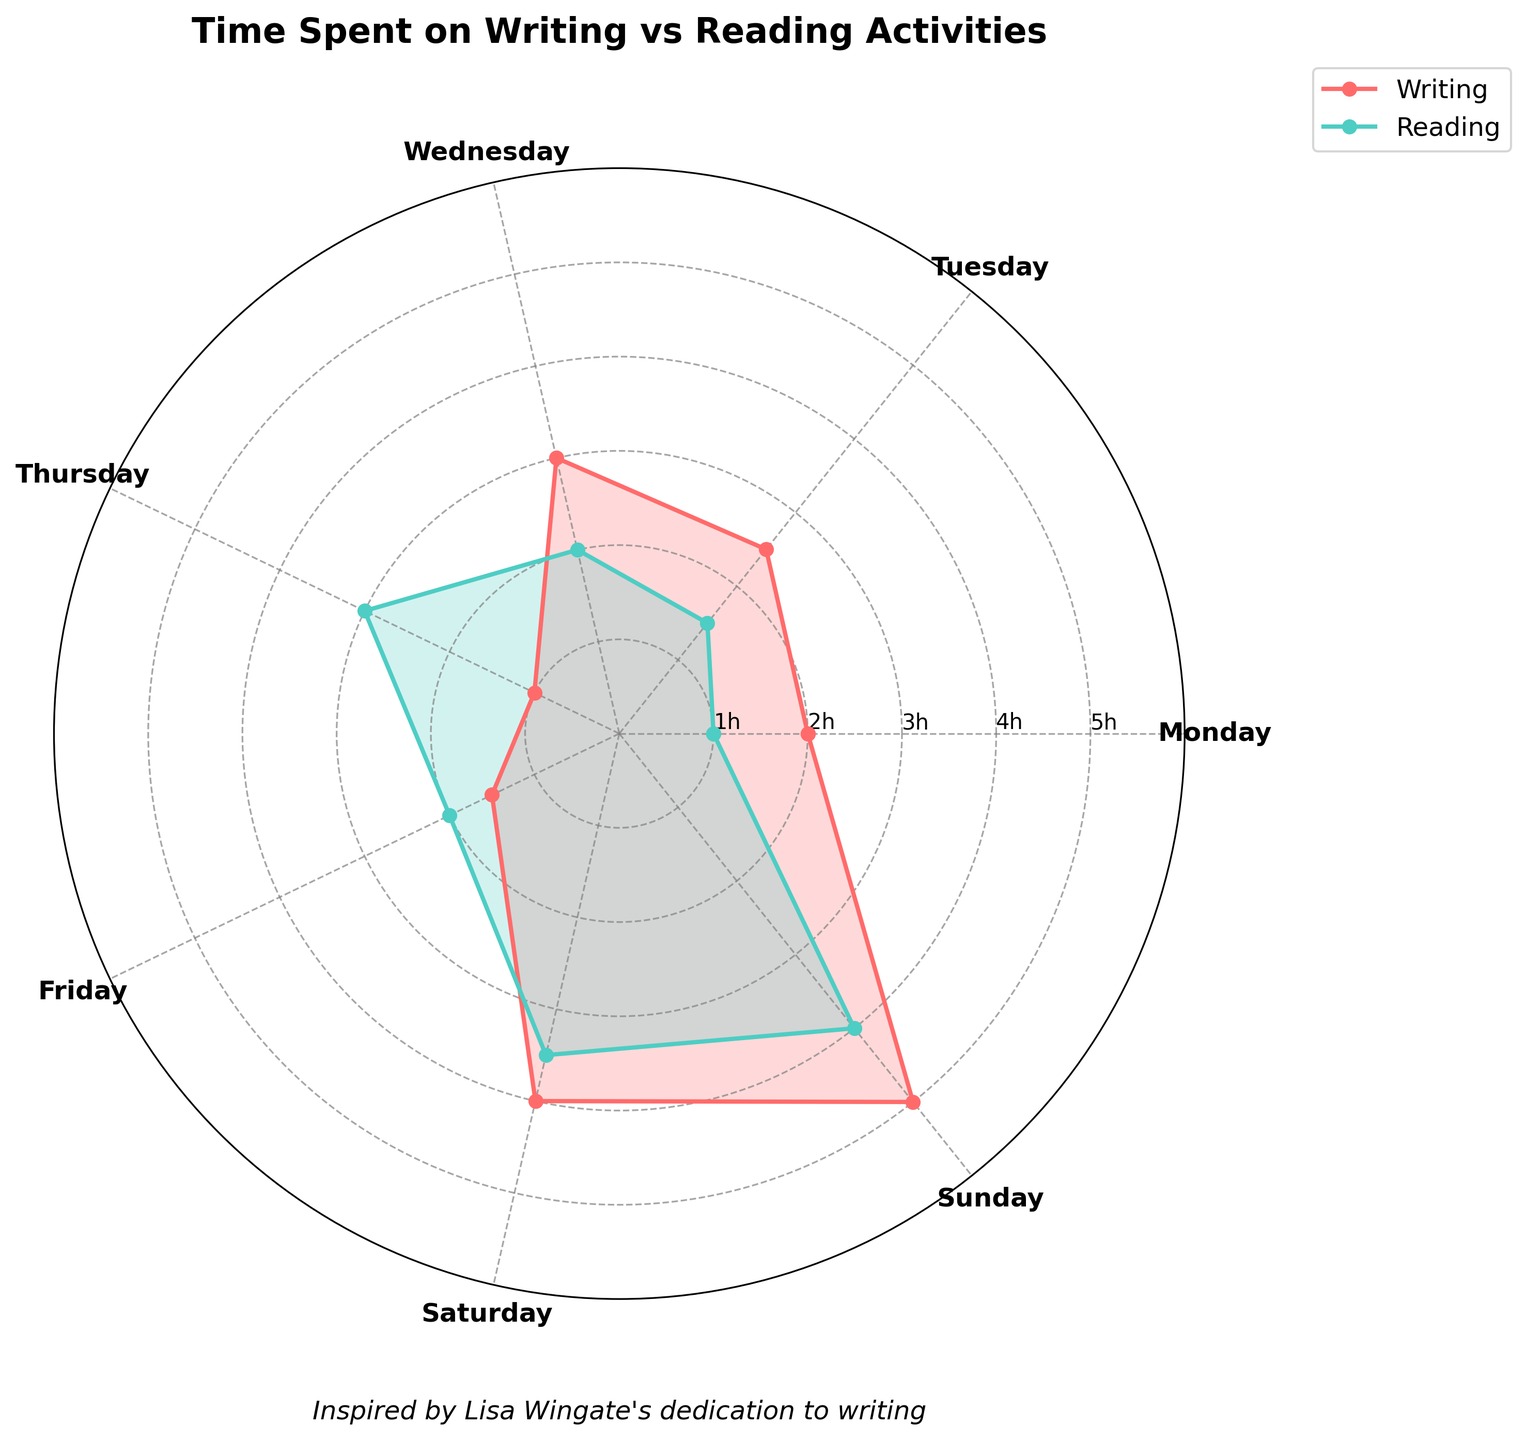What day has the highest number of hours dedicated to writing activities? The day with the highest number of hours dedicated to writing activities is Sunday. This can be observed as the plot shows the largest value for writing activities on Sunday.
Answer: Sunday How many more hours are spent on writing activities compared to reading activities on Wednesday? On Wednesday, 3 hours are spent on writing activities, and 2 hours on reading activities. Subtracting the reading hours from the writing hours gives us 3 - 2 = 1 hour.
Answer: 1 hour What is the total number of hours spent on both writing and reading activities on Thursday? On Thursday, 1 hour is spent on writing activities and 3 hours on reading activities. Summing these gives 1 + 3 = 4 hours.
Answer: 4 hours Which day has the smallest difference between writing and reading activities hours? To determine this, we should calculate the difference for each day. The smallest difference occurs when the values are closest to each other. Based on the figure, Monday (2 hours writing, 1 hour reading) shows a difference of 1 hour, which is the smallest compared to other days.
Answer: Monday By how many hours does the reading activity on Sunday exceed the reading activity on Monday? On Sunday, 4 hours are spent on reading activities, while on Monday, 1 hour is spent. Subtracting gives us 4 - 1 = 3 hours.
Answer: 3 hours What is the average number of hours spent on writing activities per day? Sum all the writing hours (2 + 2.5 + 3 + 1 + 1.5 + 4 + 5) which equals 19. Then divide by the number of days (7), giving us 19 / 7 ≈ 2.71 hours.
Answer: 2.71 hours Which day shows a greater number of hours spent on reading activities compared to writing activities? The days where reading hours exceed writing hours are Thursday (1 hour writing, 3 hours reading) and Friday (1.5 hours writing, 2 hours reading).
Answer: Thursday, Friday What is the difference between the maximum hours spent on writing activities and the maximum hours spent on reading activities? The maximum hours spent on writing activities are 5 (on Sunday), and for reading activities are 4 (on Sunday). The difference is 5 - 4 = 1 hour.
Answer: 1 hour On which day are the hours spent on writing and reading activities equal? According to the figure, there is no day where the hours spent on writing and reading activities are equal; however, they are quite close on Tuesday (2.5 hours writing, 1.5 hours reading) and Wednesday (3 hours writing, 2 hours reading).
Answer: None 